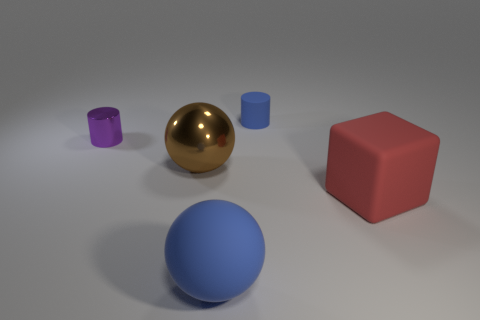Subtract 1 cylinders. How many cylinders are left? 1 Add 5 tiny blue matte cylinders. How many objects exist? 10 Subtract all cylinders. How many objects are left? 3 Subtract all red spheres. Subtract all red cubes. How many spheres are left? 2 Subtract all red matte spheres. Subtract all big shiny things. How many objects are left? 4 Add 3 large cubes. How many large cubes are left? 4 Add 1 large shiny cubes. How many large shiny cubes exist? 1 Subtract 0 cyan cubes. How many objects are left? 5 